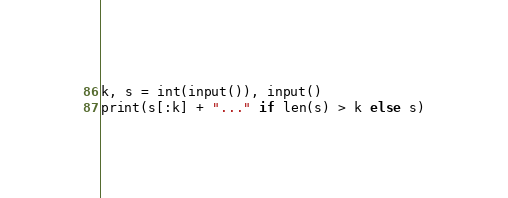Convert code to text. <code><loc_0><loc_0><loc_500><loc_500><_Python_>k, s = int(input()), input()
print(s[:k] + "..." if len(s) > k else s)</code> 